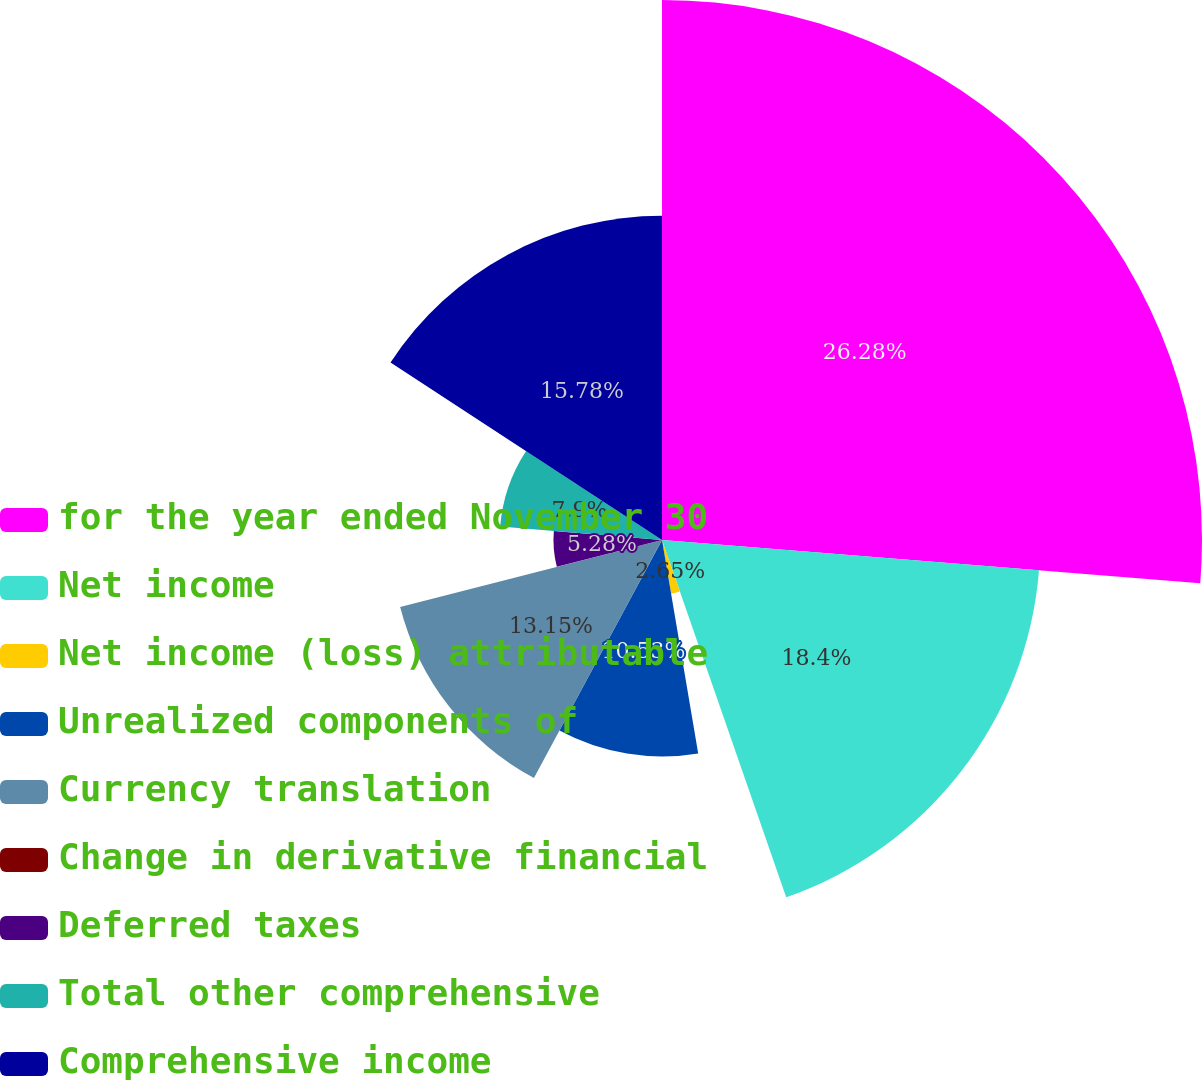<chart> <loc_0><loc_0><loc_500><loc_500><pie_chart><fcel>for the year ended November 30<fcel>Net income<fcel>Net income (loss) attributable<fcel>Unrealized components of<fcel>Currency translation<fcel>Change in derivative financial<fcel>Deferred taxes<fcel>Total other comprehensive<fcel>Comprehensive income<nl><fcel>26.27%<fcel>18.4%<fcel>2.65%<fcel>10.53%<fcel>13.15%<fcel>0.03%<fcel>5.28%<fcel>7.9%<fcel>15.78%<nl></chart> 